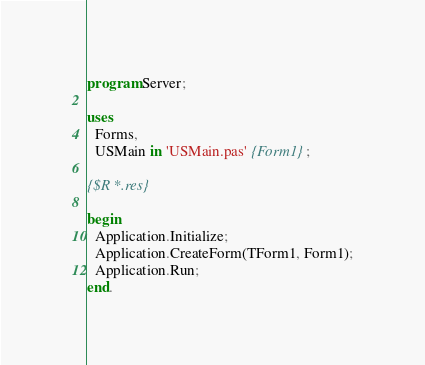Convert code to text. <code><loc_0><loc_0><loc_500><loc_500><_Pascal_>program Server;

uses
  Forms,
  USMain in 'USMain.pas' {Form1};

{$R *.res}

begin
  Application.Initialize;
  Application.CreateForm(TForm1, Form1);
  Application.Run;
end.
</code> 